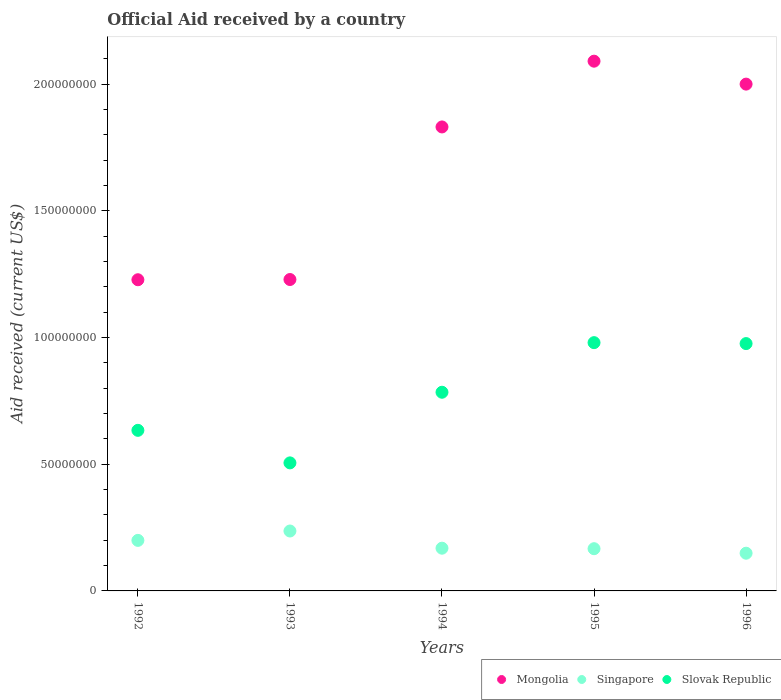What is the net official aid received in Singapore in 1992?
Provide a succinct answer. 1.99e+07. Across all years, what is the maximum net official aid received in Singapore?
Your answer should be very brief. 2.36e+07. Across all years, what is the minimum net official aid received in Slovak Republic?
Your response must be concise. 5.05e+07. In which year was the net official aid received in Slovak Republic minimum?
Offer a very short reply. 1993. What is the total net official aid received in Slovak Republic in the graph?
Offer a very short reply. 3.88e+08. What is the difference between the net official aid received in Mongolia in 1993 and that in 1996?
Keep it short and to the point. -7.71e+07. What is the difference between the net official aid received in Mongolia in 1993 and the net official aid received in Singapore in 1996?
Your response must be concise. 1.08e+08. What is the average net official aid received in Singapore per year?
Your answer should be compact. 1.84e+07. In the year 1992, what is the difference between the net official aid received in Slovak Republic and net official aid received in Mongolia?
Offer a terse response. -5.94e+07. In how many years, is the net official aid received in Slovak Republic greater than 130000000 US$?
Offer a very short reply. 0. What is the ratio of the net official aid received in Singapore in 1993 to that in 1996?
Make the answer very short. 1.59. Is the difference between the net official aid received in Slovak Republic in 1993 and 1996 greater than the difference between the net official aid received in Mongolia in 1993 and 1996?
Your answer should be compact. Yes. What is the difference between the highest and the second highest net official aid received in Mongolia?
Make the answer very short. 9.05e+06. What is the difference between the highest and the lowest net official aid received in Mongolia?
Offer a terse response. 8.62e+07. Is it the case that in every year, the sum of the net official aid received in Mongolia and net official aid received in Slovak Republic  is greater than the net official aid received in Singapore?
Provide a short and direct response. Yes. How many dotlines are there?
Keep it short and to the point. 3. What is the difference between two consecutive major ticks on the Y-axis?
Your answer should be very brief. 5.00e+07. Are the values on the major ticks of Y-axis written in scientific E-notation?
Offer a terse response. No. Does the graph contain any zero values?
Offer a very short reply. No. Does the graph contain grids?
Offer a terse response. No. Where does the legend appear in the graph?
Your answer should be very brief. Bottom right. What is the title of the graph?
Your answer should be compact. Official Aid received by a country. What is the label or title of the Y-axis?
Ensure brevity in your answer.  Aid received (current US$). What is the Aid received (current US$) of Mongolia in 1992?
Provide a succinct answer. 1.23e+08. What is the Aid received (current US$) of Singapore in 1992?
Ensure brevity in your answer.  1.99e+07. What is the Aid received (current US$) in Slovak Republic in 1992?
Your answer should be very brief. 6.34e+07. What is the Aid received (current US$) in Mongolia in 1993?
Your answer should be compact. 1.23e+08. What is the Aid received (current US$) of Singapore in 1993?
Offer a very short reply. 2.36e+07. What is the Aid received (current US$) in Slovak Republic in 1993?
Give a very brief answer. 5.05e+07. What is the Aid received (current US$) of Mongolia in 1994?
Offer a very short reply. 1.83e+08. What is the Aid received (current US$) of Singapore in 1994?
Make the answer very short. 1.69e+07. What is the Aid received (current US$) in Slovak Republic in 1994?
Offer a very short reply. 7.84e+07. What is the Aid received (current US$) of Mongolia in 1995?
Your response must be concise. 2.09e+08. What is the Aid received (current US$) in Singapore in 1995?
Ensure brevity in your answer.  1.67e+07. What is the Aid received (current US$) of Slovak Republic in 1995?
Your response must be concise. 9.80e+07. What is the Aid received (current US$) in Mongolia in 1996?
Your response must be concise. 2.00e+08. What is the Aid received (current US$) in Singapore in 1996?
Provide a short and direct response. 1.49e+07. What is the Aid received (current US$) of Slovak Republic in 1996?
Offer a very short reply. 9.76e+07. Across all years, what is the maximum Aid received (current US$) in Mongolia?
Offer a terse response. 2.09e+08. Across all years, what is the maximum Aid received (current US$) in Singapore?
Your answer should be compact. 2.36e+07. Across all years, what is the maximum Aid received (current US$) of Slovak Republic?
Offer a terse response. 9.80e+07. Across all years, what is the minimum Aid received (current US$) in Mongolia?
Your response must be concise. 1.23e+08. Across all years, what is the minimum Aid received (current US$) in Singapore?
Your answer should be very brief. 1.49e+07. Across all years, what is the minimum Aid received (current US$) in Slovak Republic?
Your response must be concise. 5.05e+07. What is the total Aid received (current US$) of Mongolia in the graph?
Offer a very short reply. 8.38e+08. What is the total Aid received (current US$) in Singapore in the graph?
Offer a terse response. 9.20e+07. What is the total Aid received (current US$) of Slovak Republic in the graph?
Keep it short and to the point. 3.88e+08. What is the difference between the Aid received (current US$) of Singapore in 1992 and that in 1993?
Make the answer very short. -3.70e+06. What is the difference between the Aid received (current US$) of Slovak Republic in 1992 and that in 1993?
Your response must be concise. 1.28e+07. What is the difference between the Aid received (current US$) of Mongolia in 1992 and that in 1994?
Give a very brief answer. -6.03e+07. What is the difference between the Aid received (current US$) in Singapore in 1992 and that in 1994?
Give a very brief answer. 3.08e+06. What is the difference between the Aid received (current US$) of Slovak Republic in 1992 and that in 1994?
Make the answer very short. -1.50e+07. What is the difference between the Aid received (current US$) of Mongolia in 1992 and that in 1995?
Offer a terse response. -8.62e+07. What is the difference between the Aid received (current US$) of Singapore in 1992 and that in 1995?
Give a very brief answer. 3.28e+06. What is the difference between the Aid received (current US$) in Slovak Republic in 1992 and that in 1995?
Ensure brevity in your answer.  -3.46e+07. What is the difference between the Aid received (current US$) in Mongolia in 1992 and that in 1996?
Give a very brief answer. -7.72e+07. What is the difference between the Aid received (current US$) in Singapore in 1992 and that in 1996?
Offer a very short reply. 5.06e+06. What is the difference between the Aid received (current US$) in Slovak Republic in 1992 and that in 1996?
Keep it short and to the point. -3.42e+07. What is the difference between the Aid received (current US$) of Mongolia in 1993 and that in 1994?
Your answer should be very brief. -6.02e+07. What is the difference between the Aid received (current US$) of Singapore in 1993 and that in 1994?
Your answer should be compact. 6.78e+06. What is the difference between the Aid received (current US$) in Slovak Republic in 1993 and that in 1994?
Give a very brief answer. -2.79e+07. What is the difference between the Aid received (current US$) of Mongolia in 1993 and that in 1995?
Give a very brief answer. -8.62e+07. What is the difference between the Aid received (current US$) of Singapore in 1993 and that in 1995?
Give a very brief answer. 6.98e+06. What is the difference between the Aid received (current US$) in Slovak Republic in 1993 and that in 1995?
Provide a short and direct response. -4.74e+07. What is the difference between the Aid received (current US$) of Mongolia in 1993 and that in 1996?
Give a very brief answer. -7.71e+07. What is the difference between the Aid received (current US$) in Singapore in 1993 and that in 1996?
Offer a very short reply. 8.76e+06. What is the difference between the Aid received (current US$) in Slovak Republic in 1993 and that in 1996?
Provide a short and direct response. -4.71e+07. What is the difference between the Aid received (current US$) in Mongolia in 1994 and that in 1995?
Offer a very short reply. -2.60e+07. What is the difference between the Aid received (current US$) of Singapore in 1994 and that in 1995?
Provide a short and direct response. 2.00e+05. What is the difference between the Aid received (current US$) in Slovak Republic in 1994 and that in 1995?
Give a very brief answer. -1.96e+07. What is the difference between the Aid received (current US$) in Mongolia in 1994 and that in 1996?
Make the answer very short. -1.69e+07. What is the difference between the Aid received (current US$) in Singapore in 1994 and that in 1996?
Make the answer very short. 1.98e+06. What is the difference between the Aid received (current US$) in Slovak Republic in 1994 and that in 1996?
Keep it short and to the point. -1.92e+07. What is the difference between the Aid received (current US$) in Mongolia in 1995 and that in 1996?
Offer a very short reply. 9.05e+06. What is the difference between the Aid received (current US$) in Singapore in 1995 and that in 1996?
Make the answer very short. 1.78e+06. What is the difference between the Aid received (current US$) in Slovak Republic in 1995 and that in 1996?
Your response must be concise. 3.70e+05. What is the difference between the Aid received (current US$) in Mongolia in 1992 and the Aid received (current US$) in Singapore in 1993?
Ensure brevity in your answer.  9.91e+07. What is the difference between the Aid received (current US$) in Mongolia in 1992 and the Aid received (current US$) in Slovak Republic in 1993?
Provide a short and direct response. 7.23e+07. What is the difference between the Aid received (current US$) in Singapore in 1992 and the Aid received (current US$) in Slovak Republic in 1993?
Make the answer very short. -3.06e+07. What is the difference between the Aid received (current US$) in Mongolia in 1992 and the Aid received (current US$) in Singapore in 1994?
Offer a terse response. 1.06e+08. What is the difference between the Aid received (current US$) of Mongolia in 1992 and the Aid received (current US$) of Slovak Republic in 1994?
Provide a short and direct response. 4.44e+07. What is the difference between the Aid received (current US$) of Singapore in 1992 and the Aid received (current US$) of Slovak Republic in 1994?
Offer a terse response. -5.84e+07. What is the difference between the Aid received (current US$) of Mongolia in 1992 and the Aid received (current US$) of Singapore in 1995?
Ensure brevity in your answer.  1.06e+08. What is the difference between the Aid received (current US$) of Mongolia in 1992 and the Aid received (current US$) of Slovak Republic in 1995?
Give a very brief answer. 2.48e+07. What is the difference between the Aid received (current US$) of Singapore in 1992 and the Aid received (current US$) of Slovak Republic in 1995?
Your answer should be compact. -7.80e+07. What is the difference between the Aid received (current US$) in Mongolia in 1992 and the Aid received (current US$) in Singapore in 1996?
Your answer should be very brief. 1.08e+08. What is the difference between the Aid received (current US$) in Mongolia in 1992 and the Aid received (current US$) in Slovak Republic in 1996?
Give a very brief answer. 2.52e+07. What is the difference between the Aid received (current US$) in Singapore in 1992 and the Aid received (current US$) in Slovak Republic in 1996?
Keep it short and to the point. -7.76e+07. What is the difference between the Aid received (current US$) in Mongolia in 1993 and the Aid received (current US$) in Singapore in 1994?
Offer a terse response. 1.06e+08. What is the difference between the Aid received (current US$) of Mongolia in 1993 and the Aid received (current US$) of Slovak Republic in 1994?
Keep it short and to the point. 4.45e+07. What is the difference between the Aid received (current US$) in Singapore in 1993 and the Aid received (current US$) in Slovak Republic in 1994?
Your response must be concise. -5.48e+07. What is the difference between the Aid received (current US$) of Mongolia in 1993 and the Aid received (current US$) of Singapore in 1995?
Offer a terse response. 1.06e+08. What is the difference between the Aid received (current US$) of Mongolia in 1993 and the Aid received (current US$) of Slovak Republic in 1995?
Ensure brevity in your answer.  2.49e+07. What is the difference between the Aid received (current US$) in Singapore in 1993 and the Aid received (current US$) in Slovak Republic in 1995?
Provide a short and direct response. -7.43e+07. What is the difference between the Aid received (current US$) in Mongolia in 1993 and the Aid received (current US$) in Singapore in 1996?
Make the answer very short. 1.08e+08. What is the difference between the Aid received (current US$) of Mongolia in 1993 and the Aid received (current US$) of Slovak Republic in 1996?
Make the answer very short. 2.53e+07. What is the difference between the Aid received (current US$) in Singapore in 1993 and the Aid received (current US$) in Slovak Republic in 1996?
Ensure brevity in your answer.  -7.40e+07. What is the difference between the Aid received (current US$) of Mongolia in 1994 and the Aid received (current US$) of Singapore in 1995?
Your answer should be very brief. 1.66e+08. What is the difference between the Aid received (current US$) of Mongolia in 1994 and the Aid received (current US$) of Slovak Republic in 1995?
Offer a terse response. 8.51e+07. What is the difference between the Aid received (current US$) in Singapore in 1994 and the Aid received (current US$) in Slovak Republic in 1995?
Give a very brief answer. -8.11e+07. What is the difference between the Aid received (current US$) in Mongolia in 1994 and the Aid received (current US$) in Singapore in 1996?
Make the answer very short. 1.68e+08. What is the difference between the Aid received (current US$) of Mongolia in 1994 and the Aid received (current US$) of Slovak Republic in 1996?
Ensure brevity in your answer.  8.55e+07. What is the difference between the Aid received (current US$) of Singapore in 1994 and the Aid received (current US$) of Slovak Republic in 1996?
Provide a succinct answer. -8.07e+07. What is the difference between the Aid received (current US$) of Mongolia in 1995 and the Aid received (current US$) of Singapore in 1996?
Offer a very short reply. 1.94e+08. What is the difference between the Aid received (current US$) in Mongolia in 1995 and the Aid received (current US$) in Slovak Republic in 1996?
Ensure brevity in your answer.  1.11e+08. What is the difference between the Aid received (current US$) of Singapore in 1995 and the Aid received (current US$) of Slovak Republic in 1996?
Your answer should be compact. -8.09e+07. What is the average Aid received (current US$) in Mongolia per year?
Keep it short and to the point. 1.68e+08. What is the average Aid received (current US$) of Singapore per year?
Ensure brevity in your answer.  1.84e+07. What is the average Aid received (current US$) of Slovak Republic per year?
Your answer should be very brief. 7.76e+07. In the year 1992, what is the difference between the Aid received (current US$) of Mongolia and Aid received (current US$) of Singapore?
Your answer should be very brief. 1.03e+08. In the year 1992, what is the difference between the Aid received (current US$) in Mongolia and Aid received (current US$) in Slovak Republic?
Keep it short and to the point. 5.94e+07. In the year 1992, what is the difference between the Aid received (current US$) of Singapore and Aid received (current US$) of Slovak Republic?
Make the answer very short. -4.34e+07. In the year 1993, what is the difference between the Aid received (current US$) of Mongolia and Aid received (current US$) of Singapore?
Give a very brief answer. 9.92e+07. In the year 1993, what is the difference between the Aid received (current US$) of Mongolia and Aid received (current US$) of Slovak Republic?
Your response must be concise. 7.24e+07. In the year 1993, what is the difference between the Aid received (current US$) in Singapore and Aid received (current US$) in Slovak Republic?
Your response must be concise. -2.69e+07. In the year 1994, what is the difference between the Aid received (current US$) in Mongolia and Aid received (current US$) in Singapore?
Provide a short and direct response. 1.66e+08. In the year 1994, what is the difference between the Aid received (current US$) in Mongolia and Aid received (current US$) in Slovak Republic?
Provide a succinct answer. 1.05e+08. In the year 1994, what is the difference between the Aid received (current US$) in Singapore and Aid received (current US$) in Slovak Republic?
Ensure brevity in your answer.  -6.15e+07. In the year 1995, what is the difference between the Aid received (current US$) of Mongolia and Aid received (current US$) of Singapore?
Provide a succinct answer. 1.92e+08. In the year 1995, what is the difference between the Aid received (current US$) in Mongolia and Aid received (current US$) in Slovak Republic?
Make the answer very short. 1.11e+08. In the year 1995, what is the difference between the Aid received (current US$) of Singapore and Aid received (current US$) of Slovak Republic?
Ensure brevity in your answer.  -8.13e+07. In the year 1996, what is the difference between the Aid received (current US$) in Mongolia and Aid received (current US$) in Singapore?
Give a very brief answer. 1.85e+08. In the year 1996, what is the difference between the Aid received (current US$) of Mongolia and Aid received (current US$) of Slovak Republic?
Your response must be concise. 1.02e+08. In the year 1996, what is the difference between the Aid received (current US$) of Singapore and Aid received (current US$) of Slovak Republic?
Keep it short and to the point. -8.27e+07. What is the ratio of the Aid received (current US$) in Singapore in 1992 to that in 1993?
Offer a terse response. 0.84. What is the ratio of the Aid received (current US$) of Slovak Republic in 1992 to that in 1993?
Keep it short and to the point. 1.25. What is the ratio of the Aid received (current US$) of Mongolia in 1992 to that in 1994?
Ensure brevity in your answer.  0.67. What is the ratio of the Aid received (current US$) of Singapore in 1992 to that in 1994?
Offer a very short reply. 1.18. What is the ratio of the Aid received (current US$) of Slovak Republic in 1992 to that in 1994?
Ensure brevity in your answer.  0.81. What is the ratio of the Aid received (current US$) of Mongolia in 1992 to that in 1995?
Offer a very short reply. 0.59. What is the ratio of the Aid received (current US$) of Singapore in 1992 to that in 1995?
Give a very brief answer. 1.2. What is the ratio of the Aid received (current US$) of Slovak Republic in 1992 to that in 1995?
Ensure brevity in your answer.  0.65. What is the ratio of the Aid received (current US$) of Mongolia in 1992 to that in 1996?
Offer a terse response. 0.61. What is the ratio of the Aid received (current US$) in Singapore in 1992 to that in 1996?
Your response must be concise. 1.34. What is the ratio of the Aid received (current US$) of Slovak Republic in 1992 to that in 1996?
Offer a terse response. 0.65. What is the ratio of the Aid received (current US$) of Mongolia in 1993 to that in 1994?
Provide a succinct answer. 0.67. What is the ratio of the Aid received (current US$) of Singapore in 1993 to that in 1994?
Give a very brief answer. 1.4. What is the ratio of the Aid received (current US$) in Slovak Republic in 1993 to that in 1994?
Keep it short and to the point. 0.64. What is the ratio of the Aid received (current US$) in Mongolia in 1993 to that in 1995?
Offer a very short reply. 0.59. What is the ratio of the Aid received (current US$) of Singapore in 1993 to that in 1995?
Give a very brief answer. 1.42. What is the ratio of the Aid received (current US$) of Slovak Republic in 1993 to that in 1995?
Make the answer very short. 0.52. What is the ratio of the Aid received (current US$) in Mongolia in 1993 to that in 1996?
Keep it short and to the point. 0.61. What is the ratio of the Aid received (current US$) in Singapore in 1993 to that in 1996?
Make the answer very short. 1.59. What is the ratio of the Aid received (current US$) in Slovak Republic in 1993 to that in 1996?
Your response must be concise. 0.52. What is the ratio of the Aid received (current US$) in Mongolia in 1994 to that in 1995?
Keep it short and to the point. 0.88. What is the ratio of the Aid received (current US$) of Slovak Republic in 1994 to that in 1995?
Ensure brevity in your answer.  0.8. What is the ratio of the Aid received (current US$) in Mongolia in 1994 to that in 1996?
Offer a terse response. 0.92. What is the ratio of the Aid received (current US$) of Singapore in 1994 to that in 1996?
Ensure brevity in your answer.  1.13. What is the ratio of the Aid received (current US$) in Slovak Republic in 1994 to that in 1996?
Offer a very short reply. 0.8. What is the ratio of the Aid received (current US$) in Mongolia in 1995 to that in 1996?
Keep it short and to the point. 1.05. What is the ratio of the Aid received (current US$) of Singapore in 1995 to that in 1996?
Offer a terse response. 1.12. What is the difference between the highest and the second highest Aid received (current US$) in Mongolia?
Ensure brevity in your answer.  9.05e+06. What is the difference between the highest and the second highest Aid received (current US$) in Singapore?
Provide a succinct answer. 3.70e+06. What is the difference between the highest and the lowest Aid received (current US$) in Mongolia?
Keep it short and to the point. 8.62e+07. What is the difference between the highest and the lowest Aid received (current US$) in Singapore?
Ensure brevity in your answer.  8.76e+06. What is the difference between the highest and the lowest Aid received (current US$) in Slovak Republic?
Provide a short and direct response. 4.74e+07. 